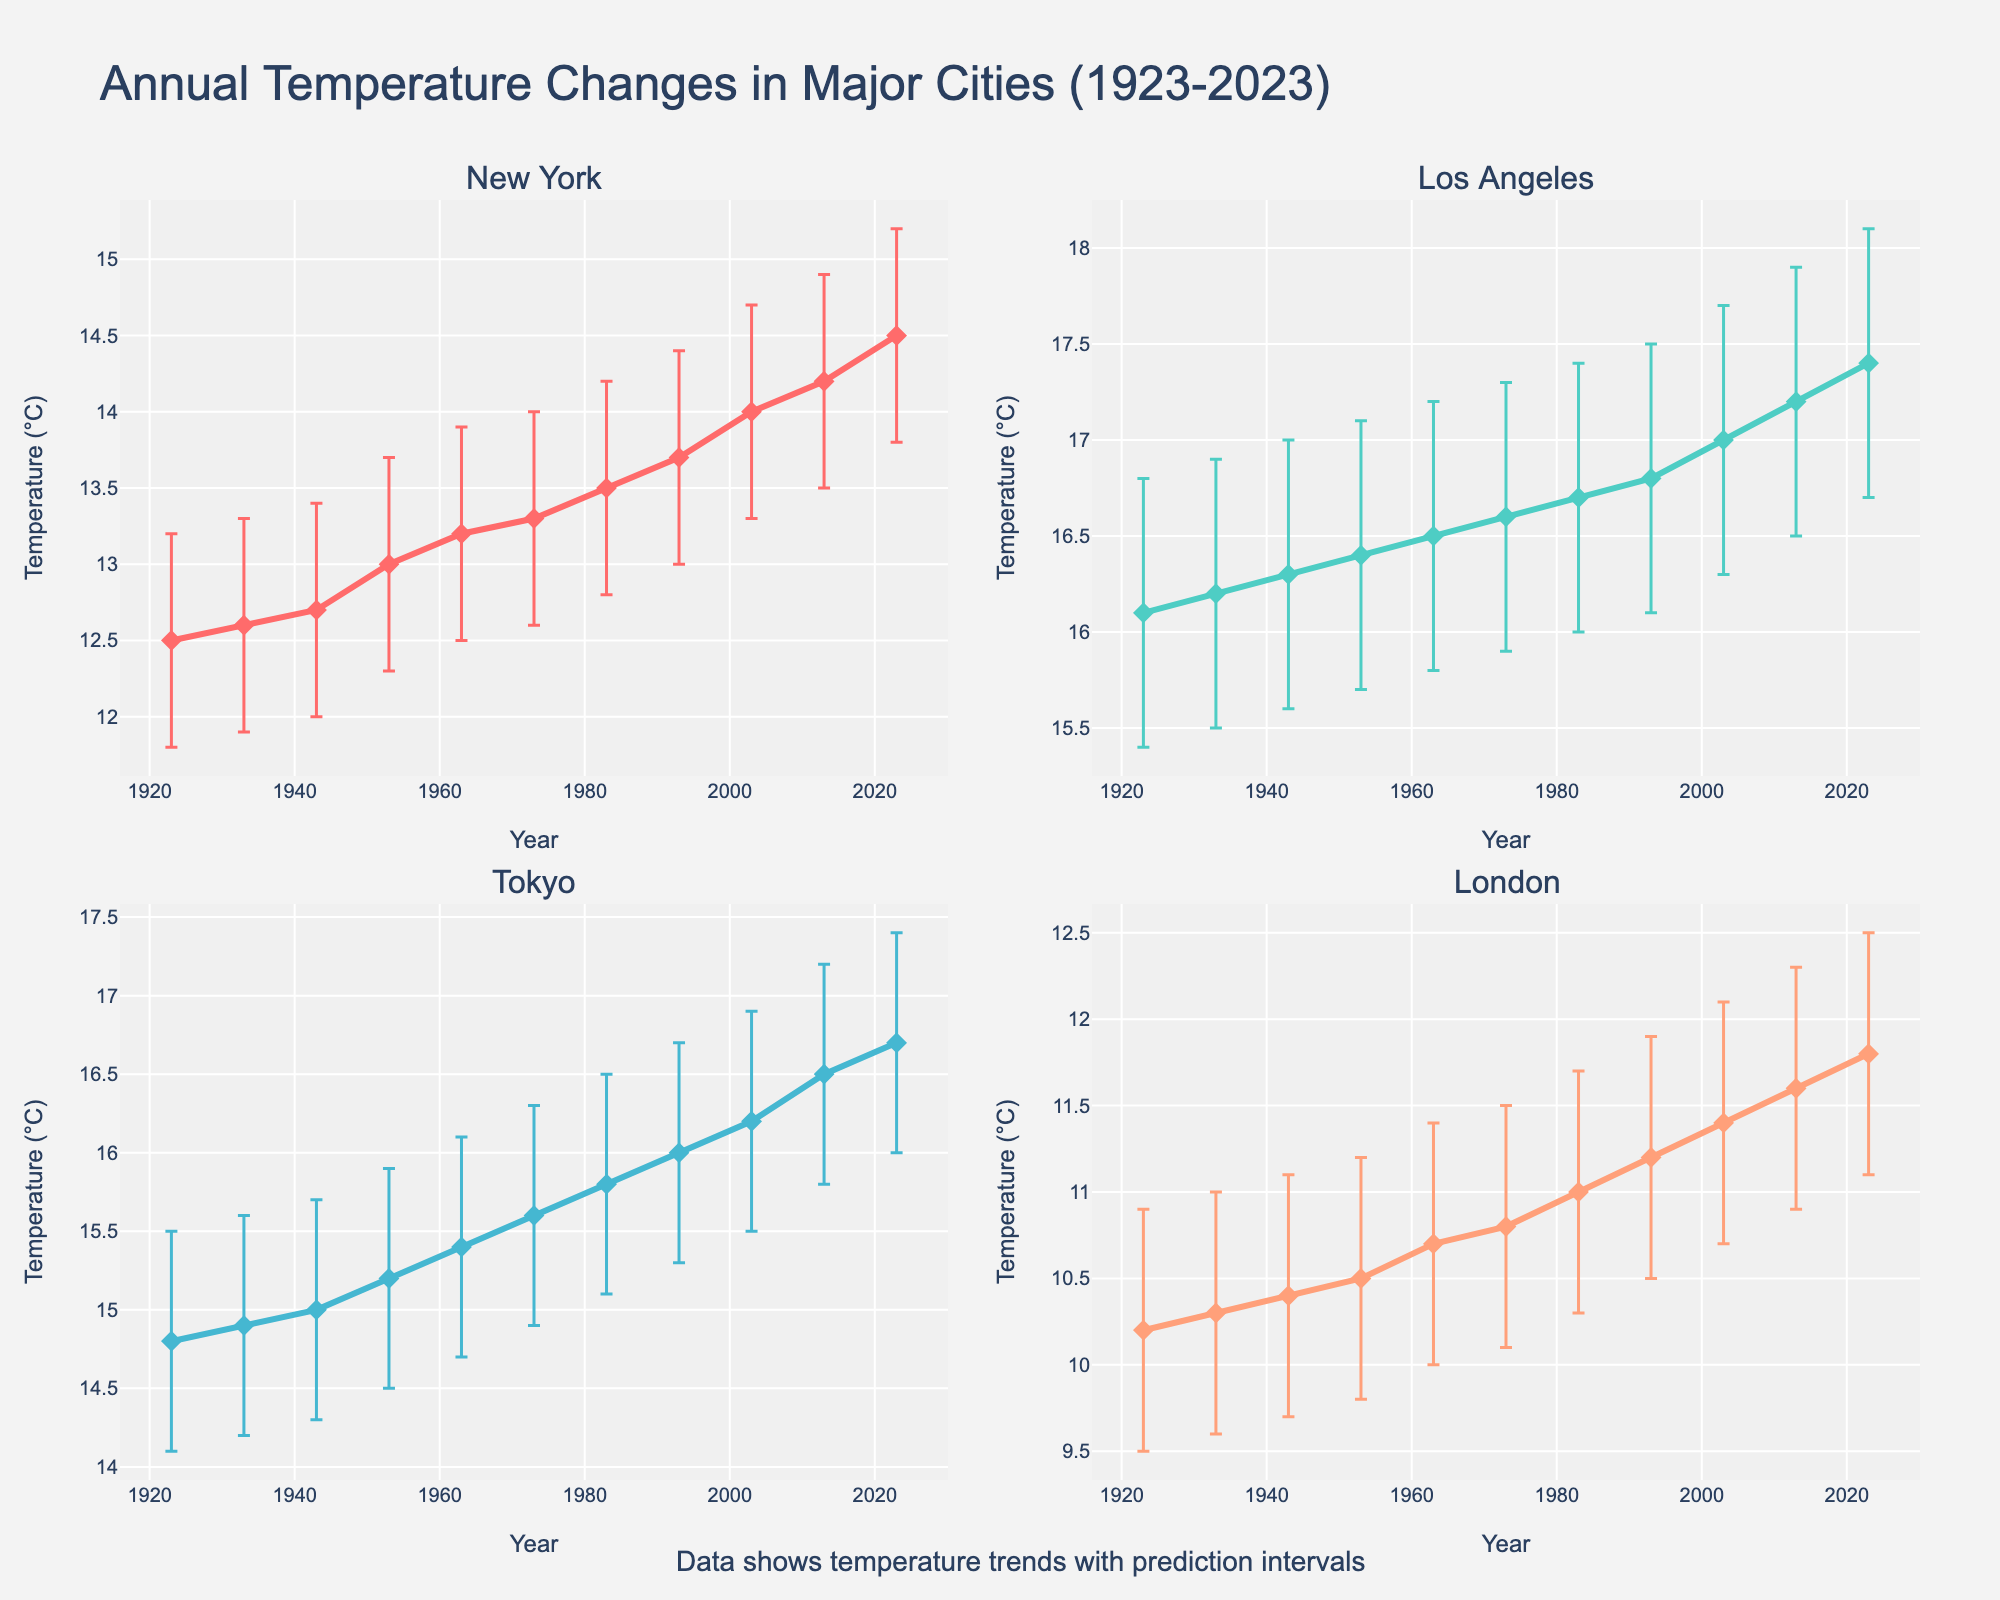What is the temperature trend in New York over the past century? Analyzing the plot for New York, observe that the average temperature increases from around 12.5°C in 1923 to approximately 14.5°C in 2023.
Answer: Rising trend Which city shows the highest average temperature in 2023? Look at the average temperature data points for 2023 in all four plots. Los Angeles has an average temperature of 17.4°C, which is higher than Tokyo, New York, and London.
Answer: Los Angeles By how much did Tokyo's average temperature increase from 1923 to 2023? Tokyo's average temperature in 1923 is 14.8°C, and in 2023 it is 16.7°C. The increase is 16.7 - 14.8.
Answer: 1.9°C Which city has the largest prediction interval in 2023? Comparing the error bars in the plots for 2023, Los Angeles has a prediction interval from 16.7°C to 18.1°C, which is the largest among the cities.
Answer: Los Angeles Did the temperature in London ever have a lower prediction interval above 10°C before 1963? Check London's plot for the years before 1963 to see if the lower prediction interval was above 10°C. It unfortunately remains below 10°C until 1963.
Answer: No In which year did New York's average temperature first exceed 13°C? New York's plot should be analyzed to find the year when the average temperature surpasses 13°C. It occurs in 1953.
Answer: 1953 Which city had the smallest temperature increase over the period from 1923 to 2023? Calculate the temperature increases for each city and compare them. London increased from 10.2°C to 11.8°C, which is the smallest increase of 1.6°C.
Answer: London How does the 1983 temperature in Los Angeles compare to the 2013 temperature in Tokyo? Check the average temperature for Los Angeles in 1983 (16.7°C) and for Tokyo in 2013 (16.5°C). Los Angeles is slightly higher.
Answer: Los Angeles is higher 